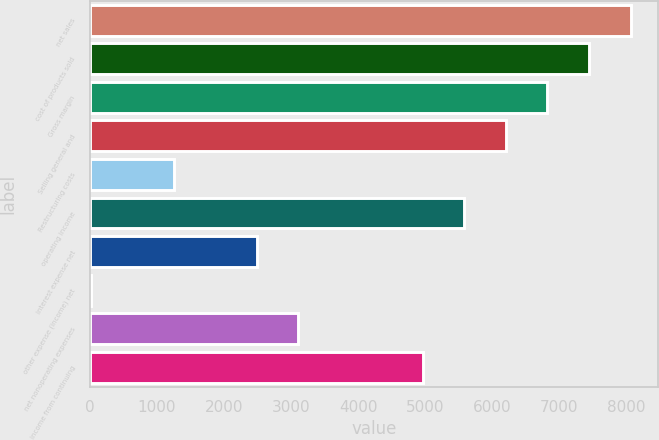<chart> <loc_0><loc_0><loc_500><loc_500><bar_chart><fcel>net sales<fcel>cost of products sold<fcel>Gross margin<fcel>Selling general and<fcel>Restructuring costs<fcel>operating income<fcel>interest expense net<fcel>other expense (income) net<fcel>net nonoperating expenses<fcel>income from continuing<nl><fcel>8058.39<fcel>7439.26<fcel>6820.13<fcel>6201<fcel>1247.96<fcel>5581.87<fcel>2486.22<fcel>9.7<fcel>3105.35<fcel>4962.74<nl></chart> 